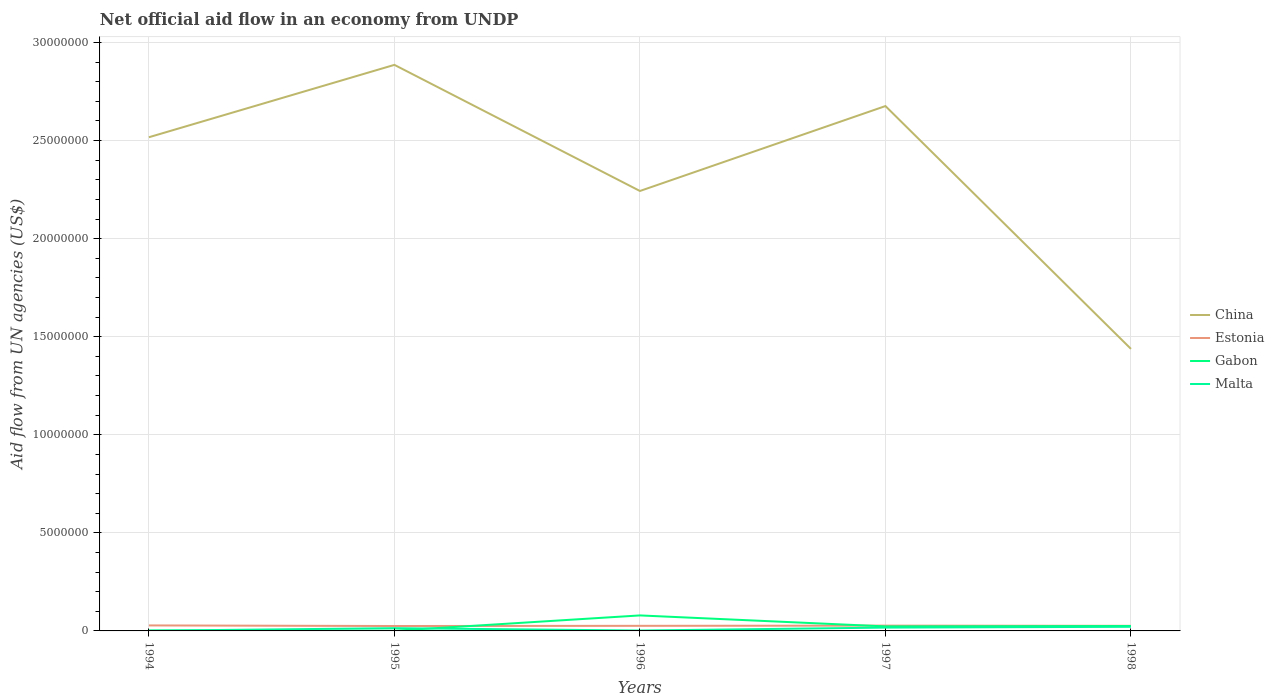How many different coloured lines are there?
Make the answer very short. 4. Across all years, what is the maximum net official aid flow in China?
Make the answer very short. 1.44e+07. What is the total net official aid flow in Gabon in the graph?
Provide a succinct answer. -2.00e+04. Is the net official aid flow in China strictly greater than the net official aid flow in Malta over the years?
Give a very brief answer. No. How many lines are there?
Ensure brevity in your answer.  4. What is the difference between two consecutive major ticks on the Y-axis?
Provide a short and direct response. 5.00e+06. Are the values on the major ticks of Y-axis written in scientific E-notation?
Keep it short and to the point. No. Where does the legend appear in the graph?
Offer a very short reply. Center right. How many legend labels are there?
Offer a terse response. 4. How are the legend labels stacked?
Your response must be concise. Vertical. What is the title of the graph?
Keep it short and to the point. Net official aid flow in an economy from UNDP. Does "Guyana" appear as one of the legend labels in the graph?
Provide a succinct answer. No. What is the label or title of the X-axis?
Make the answer very short. Years. What is the label or title of the Y-axis?
Ensure brevity in your answer.  Aid flow from UN agencies (US$). What is the Aid flow from UN agencies (US$) of China in 1994?
Your response must be concise. 2.52e+07. What is the Aid flow from UN agencies (US$) in Estonia in 1994?
Your answer should be compact. 2.80e+05. What is the Aid flow from UN agencies (US$) in China in 1995?
Ensure brevity in your answer.  2.89e+07. What is the Aid flow from UN agencies (US$) in Estonia in 1995?
Your answer should be very brief. 2.50e+05. What is the Aid flow from UN agencies (US$) of Malta in 1995?
Your answer should be compact. 1.40e+05. What is the Aid flow from UN agencies (US$) of China in 1996?
Your answer should be very brief. 2.24e+07. What is the Aid flow from UN agencies (US$) in Estonia in 1996?
Offer a very short reply. 2.60e+05. What is the Aid flow from UN agencies (US$) in Gabon in 1996?
Ensure brevity in your answer.  7.90e+05. What is the Aid flow from UN agencies (US$) in China in 1997?
Provide a short and direct response. 2.68e+07. What is the Aid flow from UN agencies (US$) of Estonia in 1997?
Offer a very short reply. 2.70e+05. What is the Aid flow from UN agencies (US$) in China in 1998?
Provide a short and direct response. 1.44e+07. What is the Aid flow from UN agencies (US$) of Gabon in 1998?
Keep it short and to the point. 2.50e+05. Across all years, what is the maximum Aid flow from UN agencies (US$) in China?
Your response must be concise. 2.89e+07. Across all years, what is the maximum Aid flow from UN agencies (US$) in Estonia?
Provide a short and direct response. 2.80e+05. Across all years, what is the maximum Aid flow from UN agencies (US$) in Gabon?
Your answer should be very brief. 7.90e+05. Across all years, what is the minimum Aid flow from UN agencies (US$) in China?
Make the answer very short. 1.44e+07. Across all years, what is the minimum Aid flow from UN agencies (US$) of Estonia?
Your answer should be very brief. 2.50e+05. Across all years, what is the minimum Aid flow from UN agencies (US$) in Gabon?
Provide a succinct answer. 10000. Across all years, what is the minimum Aid flow from UN agencies (US$) of Malta?
Make the answer very short. 10000. What is the total Aid flow from UN agencies (US$) in China in the graph?
Your answer should be very brief. 1.18e+08. What is the total Aid flow from UN agencies (US$) of Estonia in the graph?
Ensure brevity in your answer.  1.32e+06. What is the total Aid flow from UN agencies (US$) of Gabon in the graph?
Keep it short and to the point. 1.30e+06. What is the difference between the Aid flow from UN agencies (US$) of China in 1994 and that in 1995?
Provide a succinct answer. -3.69e+06. What is the difference between the Aid flow from UN agencies (US$) in Gabon in 1994 and that in 1995?
Provide a succinct answer. 10000. What is the difference between the Aid flow from UN agencies (US$) in China in 1994 and that in 1996?
Offer a terse response. 2.74e+06. What is the difference between the Aid flow from UN agencies (US$) of Estonia in 1994 and that in 1996?
Your answer should be compact. 2.00e+04. What is the difference between the Aid flow from UN agencies (US$) in Gabon in 1994 and that in 1996?
Provide a succinct answer. -7.70e+05. What is the difference between the Aid flow from UN agencies (US$) in China in 1994 and that in 1997?
Give a very brief answer. -1.59e+06. What is the difference between the Aid flow from UN agencies (US$) of China in 1994 and that in 1998?
Offer a terse response. 1.08e+07. What is the difference between the Aid flow from UN agencies (US$) in Estonia in 1994 and that in 1998?
Offer a terse response. 2.00e+04. What is the difference between the Aid flow from UN agencies (US$) in Gabon in 1994 and that in 1998?
Make the answer very short. -2.30e+05. What is the difference between the Aid flow from UN agencies (US$) of Malta in 1994 and that in 1998?
Offer a terse response. -2.00e+05. What is the difference between the Aid flow from UN agencies (US$) of China in 1995 and that in 1996?
Provide a succinct answer. 6.43e+06. What is the difference between the Aid flow from UN agencies (US$) in Gabon in 1995 and that in 1996?
Keep it short and to the point. -7.80e+05. What is the difference between the Aid flow from UN agencies (US$) in China in 1995 and that in 1997?
Keep it short and to the point. 2.10e+06. What is the difference between the Aid flow from UN agencies (US$) of Estonia in 1995 and that in 1997?
Your answer should be compact. -2.00e+04. What is the difference between the Aid flow from UN agencies (US$) in Gabon in 1995 and that in 1997?
Provide a short and direct response. -2.20e+05. What is the difference between the Aid flow from UN agencies (US$) of China in 1995 and that in 1998?
Your response must be concise. 1.45e+07. What is the difference between the Aid flow from UN agencies (US$) of Estonia in 1995 and that in 1998?
Give a very brief answer. -10000. What is the difference between the Aid flow from UN agencies (US$) in Gabon in 1995 and that in 1998?
Your answer should be very brief. -2.40e+05. What is the difference between the Aid flow from UN agencies (US$) of China in 1996 and that in 1997?
Your answer should be compact. -4.33e+06. What is the difference between the Aid flow from UN agencies (US$) in Gabon in 1996 and that in 1997?
Provide a succinct answer. 5.60e+05. What is the difference between the Aid flow from UN agencies (US$) of Malta in 1996 and that in 1997?
Provide a short and direct response. -1.50e+05. What is the difference between the Aid flow from UN agencies (US$) of China in 1996 and that in 1998?
Your answer should be compact. 8.05e+06. What is the difference between the Aid flow from UN agencies (US$) in Estonia in 1996 and that in 1998?
Make the answer very short. 0. What is the difference between the Aid flow from UN agencies (US$) of Gabon in 1996 and that in 1998?
Ensure brevity in your answer.  5.40e+05. What is the difference between the Aid flow from UN agencies (US$) in China in 1997 and that in 1998?
Your response must be concise. 1.24e+07. What is the difference between the Aid flow from UN agencies (US$) in Estonia in 1997 and that in 1998?
Make the answer very short. 10000. What is the difference between the Aid flow from UN agencies (US$) in China in 1994 and the Aid flow from UN agencies (US$) in Estonia in 1995?
Your answer should be compact. 2.49e+07. What is the difference between the Aid flow from UN agencies (US$) of China in 1994 and the Aid flow from UN agencies (US$) of Gabon in 1995?
Keep it short and to the point. 2.52e+07. What is the difference between the Aid flow from UN agencies (US$) of China in 1994 and the Aid flow from UN agencies (US$) of Malta in 1995?
Your answer should be very brief. 2.50e+07. What is the difference between the Aid flow from UN agencies (US$) in Estonia in 1994 and the Aid flow from UN agencies (US$) in Gabon in 1995?
Offer a terse response. 2.70e+05. What is the difference between the Aid flow from UN agencies (US$) in Estonia in 1994 and the Aid flow from UN agencies (US$) in Malta in 1995?
Your response must be concise. 1.40e+05. What is the difference between the Aid flow from UN agencies (US$) in Gabon in 1994 and the Aid flow from UN agencies (US$) in Malta in 1995?
Your response must be concise. -1.20e+05. What is the difference between the Aid flow from UN agencies (US$) in China in 1994 and the Aid flow from UN agencies (US$) in Estonia in 1996?
Provide a succinct answer. 2.49e+07. What is the difference between the Aid flow from UN agencies (US$) in China in 1994 and the Aid flow from UN agencies (US$) in Gabon in 1996?
Make the answer very short. 2.44e+07. What is the difference between the Aid flow from UN agencies (US$) of China in 1994 and the Aid flow from UN agencies (US$) of Malta in 1996?
Offer a terse response. 2.52e+07. What is the difference between the Aid flow from UN agencies (US$) of Estonia in 1994 and the Aid flow from UN agencies (US$) of Gabon in 1996?
Provide a succinct answer. -5.10e+05. What is the difference between the Aid flow from UN agencies (US$) in Gabon in 1994 and the Aid flow from UN agencies (US$) in Malta in 1996?
Keep it short and to the point. 0. What is the difference between the Aid flow from UN agencies (US$) of China in 1994 and the Aid flow from UN agencies (US$) of Estonia in 1997?
Offer a terse response. 2.49e+07. What is the difference between the Aid flow from UN agencies (US$) in China in 1994 and the Aid flow from UN agencies (US$) in Gabon in 1997?
Provide a succinct answer. 2.49e+07. What is the difference between the Aid flow from UN agencies (US$) in China in 1994 and the Aid flow from UN agencies (US$) in Malta in 1997?
Your response must be concise. 2.50e+07. What is the difference between the Aid flow from UN agencies (US$) of Gabon in 1994 and the Aid flow from UN agencies (US$) of Malta in 1997?
Your answer should be very brief. -1.50e+05. What is the difference between the Aid flow from UN agencies (US$) in China in 1994 and the Aid flow from UN agencies (US$) in Estonia in 1998?
Keep it short and to the point. 2.49e+07. What is the difference between the Aid flow from UN agencies (US$) of China in 1994 and the Aid flow from UN agencies (US$) of Gabon in 1998?
Offer a very short reply. 2.49e+07. What is the difference between the Aid flow from UN agencies (US$) in China in 1994 and the Aid flow from UN agencies (US$) in Malta in 1998?
Your response must be concise. 2.50e+07. What is the difference between the Aid flow from UN agencies (US$) in Estonia in 1994 and the Aid flow from UN agencies (US$) in Gabon in 1998?
Offer a very short reply. 3.00e+04. What is the difference between the Aid flow from UN agencies (US$) in Estonia in 1994 and the Aid flow from UN agencies (US$) in Malta in 1998?
Give a very brief answer. 7.00e+04. What is the difference between the Aid flow from UN agencies (US$) in Gabon in 1994 and the Aid flow from UN agencies (US$) in Malta in 1998?
Give a very brief answer. -1.90e+05. What is the difference between the Aid flow from UN agencies (US$) of China in 1995 and the Aid flow from UN agencies (US$) of Estonia in 1996?
Give a very brief answer. 2.86e+07. What is the difference between the Aid flow from UN agencies (US$) of China in 1995 and the Aid flow from UN agencies (US$) of Gabon in 1996?
Offer a very short reply. 2.81e+07. What is the difference between the Aid flow from UN agencies (US$) of China in 1995 and the Aid flow from UN agencies (US$) of Malta in 1996?
Offer a terse response. 2.88e+07. What is the difference between the Aid flow from UN agencies (US$) of Estonia in 1995 and the Aid flow from UN agencies (US$) of Gabon in 1996?
Your answer should be very brief. -5.40e+05. What is the difference between the Aid flow from UN agencies (US$) in Estonia in 1995 and the Aid flow from UN agencies (US$) in Malta in 1996?
Keep it short and to the point. 2.30e+05. What is the difference between the Aid flow from UN agencies (US$) in China in 1995 and the Aid flow from UN agencies (US$) in Estonia in 1997?
Keep it short and to the point. 2.86e+07. What is the difference between the Aid flow from UN agencies (US$) in China in 1995 and the Aid flow from UN agencies (US$) in Gabon in 1997?
Give a very brief answer. 2.86e+07. What is the difference between the Aid flow from UN agencies (US$) in China in 1995 and the Aid flow from UN agencies (US$) in Malta in 1997?
Keep it short and to the point. 2.87e+07. What is the difference between the Aid flow from UN agencies (US$) in Estonia in 1995 and the Aid flow from UN agencies (US$) in Malta in 1997?
Offer a terse response. 8.00e+04. What is the difference between the Aid flow from UN agencies (US$) of Gabon in 1995 and the Aid flow from UN agencies (US$) of Malta in 1997?
Make the answer very short. -1.60e+05. What is the difference between the Aid flow from UN agencies (US$) of China in 1995 and the Aid flow from UN agencies (US$) of Estonia in 1998?
Provide a succinct answer. 2.86e+07. What is the difference between the Aid flow from UN agencies (US$) of China in 1995 and the Aid flow from UN agencies (US$) of Gabon in 1998?
Make the answer very short. 2.86e+07. What is the difference between the Aid flow from UN agencies (US$) in China in 1995 and the Aid flow from UN agencies (US$) in Malta in 1998?
Provide a succinct answer. 2.86e+07. What is the difference between the Aid flow from UN agencies (US$) in China in 1996 and the Aid flow from UN agencies (US$) in Estonia in 1997?
Provide a short and direct response. 2.22e+07. What is the difference between the Aid flow from UN agencies (US$) of China in 1996 and the Aid flow from UN agencies (US$) of Gabon in 1997?
Keep it short and to the point. 2.22e+07. What is the difference between the Aid flow from UN agencies (US$) in China in 1996 and the Aid flow from UN agencies (US$) in Malta in 1997?
Your answer should be very brief. 2.23e+07. What is the difference between the Aid flow from UN agencies (US$) of Gabon in 1996 and the Aid flow from UN agencies (US$) of Malta in 1997?
Your answer should be compact. 6.20e+05. What is the difference between the Aid flow from UN agencies (US$) of China in 1996 and the Aid flow from UN agencies (US$) of Estonia in 1998?
Ensure brevity in your answer.  2.22e+07. What is the difference between the Aid flow from UN agencies (US$) of China in 1996 and the Aid flow from UN agencies (US$) of Gabon in 1998?
Ensure brevity in your answer.  2.22e+07. What is the difference between the Aid flow from UN agencies (US$) of China in 1996 and the Aid flow from UN agencies (US$) of Malta in 1998?
Offer a terse response. 2.22e+07. What is the difference between the Aid flow from UN agencies (US$) in Estonia in 1996 and the Aid flow from UN agencies (US$) in Gabon in 1998?
Your answer should be compact. 10000. What is the difference between the Aid flow from UN agencies (US$) in Gabon in 1996 and the Aid flow from UN agencies (US$) in Malta in 1998?
Your answer should be very brief. 5.80e+05. What is the difference between the Aid flow from UN agencies (US$) of China in 1997 and the Aid flow from UN agencies (US$) of Estonia in 1998?
Your answer should be compact. 2.65e+07. What is the difference between the Aid flow from UN agencies (US$) of China in 1997 and the Aid flow from UN agencies (US$) of Gabon in 1998?
Provide a short and direct response. 2.65e+07. What is the difference between the Aid flow from UN agencies (US$) in China in 1997 and the Aid flow from UN agencies (US$) in Malta in 1998?
Your response must be concise. 2.66e+07. What is the difference between the Aid flow from UN agencies (US$) of Estonia in 1997 and the Aid flow from UN agencies (US$) of Gabon in 1998?
Offer a terse response. 2.00e+04. What is the difference between the Aid flow from UN agencies (US$) of Gabon in 1997 and the Aid flow from UN agencies (US$) of Malta in 1998?
Give a very brief answer. 2.00e+04. What is the average Aid flow from UN agencies (US$) of China per year?
Your answer should be compact. 2.35e+07. What is the average Aid flow from UN agencies (US$) in Estonia per year?
Your answer should be very brief. 2.64e+05. In the year 1994, what is the difference between the Aid flow from UN agencies (US$) in China and Aid flow from UN agencies (US$) in Estonia?
Provide a succinct answer. 2.49e+07. In the year 1994, what is the difference between the Aid flow from UN agencies (US$) in China and Aid flow from UN agencies (US$) in Gabon?
Your answer should be very brief. 2.52e+07. In the year 1994, what is the difference between the Aid flow from UN agencies (US$) of China and Aid flow from UN agencies (US$) of Malta?
Ensure brevity in your answer.  2.52e+07. In the year 1994, what is the difference between the Aid flow from UN agencies (US$) in Estonia and Aid flow from UN agencies (US$) in Gabon?
Provide a short and direct response. 2.60e+05. In the year 1994, what is the difference between the Aid flow from UN agencies (US$) in Estonia and Aid flow from UN agencies (US$) in Malta?
Give a very brief answer. 2.70e+05. In the year 1994, what is the difference between the Aid flow from UN agencies (US$) in Gabon and Aid flow from UN agencies (US$) in Malta?
Make the answer very short. 10000. In the year 1995, what is the difference between the Aid flow from UN agencies (US$) in China and Aid flow from UN agencies (US$) in Estonia?
Provide a succinct answer. 2.86e+07. In the year 1995, what is the difference between the Aid flow from UN agencies (US$) of China and Aid flow from UN agencies (US$) of Gabon?
Your answer should be very brief. 2.88e+07. In the year 1995, what is the difference between the Aid flow from UN agencies (US$) of China and Aid flow from UN agencies (US$) of Malta?
Provide a short and direct response. 2.87e+07. In the year 1996, what is the difference between the Aid flow from UN agencies (US$) in China and Aid flow from UN agencies (US$) in Estonia?
Provide a short and direct response. 2.22e+07. In the year 1996, what is the difference between the Aid flow from UN agencies (US$) of China and Aid flow from UN agencies (US$) of Gabon?
Your answer should be very brief. 2.16e+07. In the year 1996, what is the difference between the Aid flow from UN agencies (US$) of China and Aid flow from UN agencies (US$) of Malta?
Provide a succinct answer. 2.24e+07. In the year 1996, what is the difference between the Aid flow from UN agencies (US$) of Estonia and Aid flow from UN agencies (US$) of Gabon?
Your answer should be compact. -5.30e+05. In the year 1996, what is the difference between the Aid flow from UN agencies (US$) in Estonia and Aid flow from UN agencies (US$) in Malta?
Your answer should be very brief. 2.40e+05. In the year 1996, what is the difference between the Aid flow from UN agencies (US$) in Gabon and Aid flow from UN agencies (US$) in Malta?
Your answer should be compact. 7.70e+05. In the year 1997, what is the difference between the Aid flow from UN agencies (US$) in China and Aid flow from UN agencies (US$) in Estonia?
Provide a short and direct response. 2.65e+07. In the year 1997, what is the difference between the Aid flow from UN agencies (US$) of China and Aid flow from UN agencies (US$) of Gabon?
Make the answer very short. 2.65e+07. In the year 1997, what is the difference between the Aid flow from UN agencies (US$) of China and Aid flow from UN agencies (US$) of Malta?
Your response must be concise. 2.66e+07. In the year 1997, what is the difference between the Aid flow from UN agencies (US$) of Estonia and Aid flow from UN agencies (US$) of Gabon?
Your answer should be very brief. 4.00e+04. In the year 1997, what is the difference between the Aid flow from UN agencies (US$) in Estonia and Aid flow from UN agencies (US$) in Malta?
Keep it short and to the point. 1.00e+05. In the year 1997, what is the difference between the Aid flow from UN agencies (US$) in Gabon and Aid flow from UN agencies (US$) in Malta?
Your response must be concise. 6.00e+04. In the year 1998, what is the difference between the Aid flow from UN agencies (US$) in China and Aid flow from UN agencies (US$) in Estonia?
Provide a succinct answer. 1.41e+07. In the year 1998, what is the difference between the Aid flow from UN agencies (US$) in China and Aid flow from UN agencies (US$) in Gabon?
Provide a succinct answer. 1.41e+07. In the year 1998, what is the difference between the Aid flow from UN agencies (US$) in China and Aid flow from UN agencies (US$) in Malta?
Offer a terse response. 1.42e+07. In the year 1998, what is the difference between the Aid flow from UN agencies (US$) of Estonia and Aid flow from UN agencies (US$) of Gabon?
Make the answer very short. 10000. In the year 1998, what is the difference between the Aid flow from UN agencies (US$) of Estonia and Aid flow from UN agencies (US$) of Malta?
Provide a succinct answer. 5.00e+04. In the year 1998, what is the difference between the Aid flow from UN agencies (US$) in Gabon and Aid flow from UN agencies (US$) in Malta?
Offer a very short reply. 4.00e+04. What is the ratio of the Aid flow from UN agencies (US$) of China in 1994 to that in 1995?
Make the answer very short. 0.87. What is the ratio of the Aid flow from UN agencies (US$) of Estonia in 1994 to that in 1995?
Ensure brevity in your answer.  1.12. What is the ratio of the Aid flow from UN agencies (US$) of Malta in 1994 to that in 1995?
Make the answer very short. 0.07. What is the ratio of the Aid flow from UN agencies (US$) of China in 1994 to that in 1996?
Provide a short and direct response. 1.12. What is the ratio of the Aid flow from UN agencies (US$) of Gabon in 1994 to that in 1996?
Ensure brevity in your answer.  0.03. What is the ratio of the Aid flow from UN agencies (US$) of Malta in 1994 to that in 1996?
Your answer should be very brief. 0.5. What is the ratio of the Aid flow from UN agencies (US$) in China in 1994 to that in 1997?
Keep it short and to the point. 0.94. What is the ratio of the Aid flow from UN agencies (US$) in Estonia in 1994 to that in 1997?
Ensure brevity in your answer.  1.04. What is the ratio of the Aid flow from UN agencies (US$) of Gabon in 1994 to that in 1997?
Provide a short and direct response. 0.09. What is the ratio of the Aid flow from UN agencies (US$) of Malta in 1994 to that in 1997?
Provide a succinct answer. 0.06. What is the ratio of the Aid flow from UN agencies (US$) of China in 1994 to that in 1998?
Ensure brevity in your answer.  1.75. What is the ratio of the Aid flow from UN agencies (US$) in Gabon in 1994 to that in 1998?
Make the answer very short. 0.08. What is the ratio of the Aid flow from UN agencies (US$) in Malta in 1994 to that in 1998?
Your answer should be very brief. 0.05. What is the ratio of the Aid flow from UN agencies (US$) of China in 1995 to that in 1996?
Your answer should be very brief. 1.29. What is the ratio of the Aid flow from UN agencies (US$) of Estonia in 1995 to that in 1996?
Make the answer very short. 0.96. What is the ratio of the Aid flow from UN agencies (US$) of Gabon in 1995 to that in 1996?
Offer a very short reply. 0.01. What is the ratio of the Aid flow from UN agencies (US$) in China in 1995 to that in 1997?
Give a very brief answer. 1.08. What is the ratio of the Aid flow from UN agencies (US$) of Estonia in 1995 to that in 1997?
Your answer should be very brief. 0.93. What is the ratio of the Aid flow from UN agencies (US$) of Gabon in 1995 to that in 1997?
Keep it short and to the point. 0.04. What is the ratio of the Aid flow from UN agencies (US$) in Malta in 1995 to that in 1997?
Provide a succinct answer. 0.82. What is the ratio of the Aid flow from UN agencies (US$) of China in 1995 to that in 1998?
Provide a short and direct response. 2.01. What is the ratio of the Aid flow from UN agencies (US$) in Estonia in 1995 to that in 1998?
Offer a terse response. 0.96. What is the ratio of the Aid flow from UN agencies (US$) of Gabon in 1995 to that in 1998?
Your answer should be very brief. 0.04. What is the ratio of the Aid flow from UN agencies (US$) of Malta in 1995 to that in 1998?
Keep it short and to the point. 0.67. What is the ratio of the Aid flow from UN agencies (US$) in China in 1996 to that in 1997?
Keep it short and to the point. 0.84. What is the ratio of the Aid flow from UN agencies (US$) of Estonia in 1996 to that in 1997?
Keep it short and to the point. 0.96. What is the ratio of the Aid flow from UN agencies (US$) in Gabon in 1996 to that in 1997?
Provide a succinct answer. 3.43. What is the ratio of the Aid flow from UN agencies (US$) in Malta in 1996 to that in 1997?
Make the answer very short. 0.12. What is the ratio of the Aid flow from UN agencies (US$) in China in 1996 to that in 1998?
Offer a very short reply. 1.56. What is the ratio of the Aid flow from UN agencies (US$) in Gabon in 1996 to that in 1998?
Keep it short and to the point. 3.16. What is the ratio of the Aid flow from UN agencies (US$) of Malta in 1996 to that in 1998?
Ensure brevity in your answer.  0.1. What is the ratio of the Aid flow from UN agencies (US$) of China in 1997 to that in 1998?
Offer a very short reply. 1.86. What is the ratio of the Aid flow from UN agencies (US$) in Malta in 1997 to that in 1998?
Offer a very short reply. 0.81. What is the difference between the highest and the second highest Aid flow from UN agencies (US$) of China?
Offer a very short reply. 2.10e+06. What is the difference between the highest and the second highest Aid flow from UN agencies (US$) in Gabon?
Your answer should be very brief. 5.40e+05. What is the difference between the highest and the lowest Aid flow from UN agencies (US$) in China?
Your answer should be compact. 1.45e+07. What is the difference between the highest and the lowest Aid flow from UN agencies (US$) of Estonia?
Your answer should be compact. 3.00e+04. What is the difference between the highest and the lowest Aid flow from UN agencies (US$) in Gabon?
Make the answer very short. 7.80e+05. What is the difference between the highest and the lowest Aid flow from UN agencies (US$) in Malta?
Offer a terse response. 2.00e+05. 